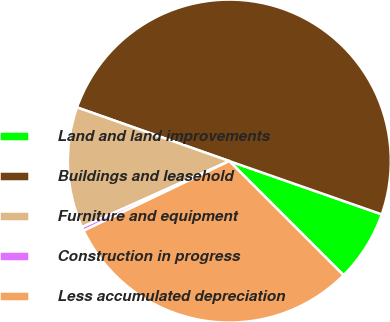<chart> <loc_0><loc_0><loc_500><loc_500><pie_chart><fcel>Land and land improvements<fcel>Buildings and leasehold<fcel>Furniture and equipment<fcel>Construction in progress<fcel>Less accumulated depreciation<nl><fcel>7.14%<fcel>49.96%<fcel>12.1%<fcel>0.39%<fcel>30.41%<nl></chart> 